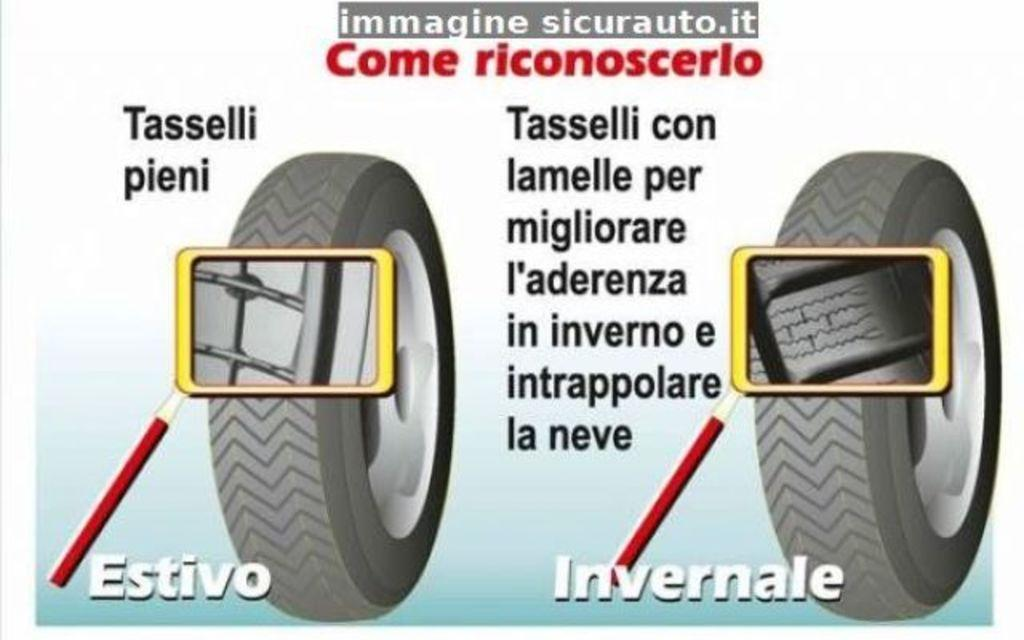What is the main object in the image? There is a poster in the image. What is depicted on the poster? The poster contains magnifying glasses attached to sticks. Does the poster have any additional features? Yes, the poster has wheels. What can be found on the poster besides the magnifying glasses? There are texts on the poster. Is the poster sinking in quicksand in the image? There is no quicksand present in the image, and the poster is not sinking. What is the plot of the story depicted on the poster? The image does not depict a story or plot; it is a poster with magnifying glasses attached to sticks, wheels, and texts. 